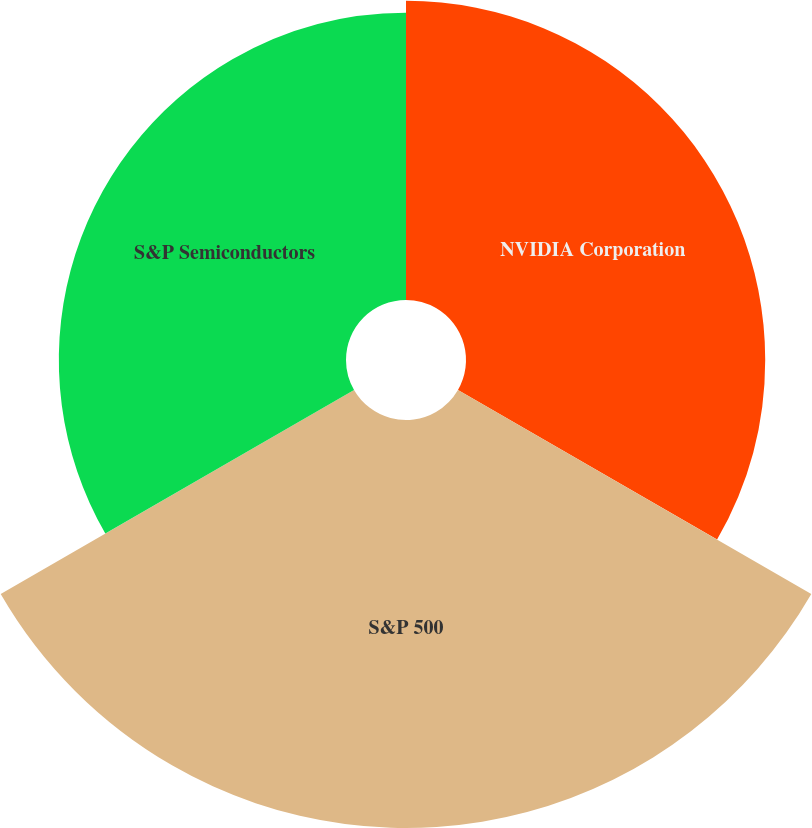Convert chart to OTSL. <chart><loc_0><loc_0><loc_500><loc_500><pie_chart><fcel>NVIDIA Corporation<fcel>S&P 500<fcel>S&P Semiconductors<nl><fcel>30.09%<fcel>41.03%<fcel>28.88%<nl></chart> 